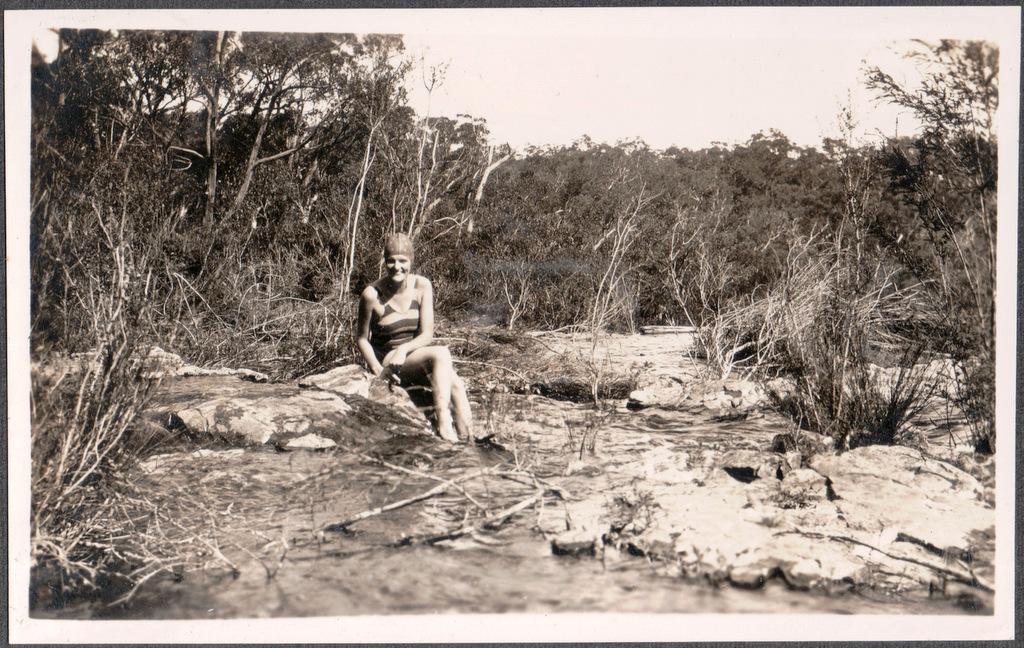Could you give a brief overview of what you see in this image? This is a black and white image. In this image we can see a woman sitting on the rocks, running water, trees and sky. 